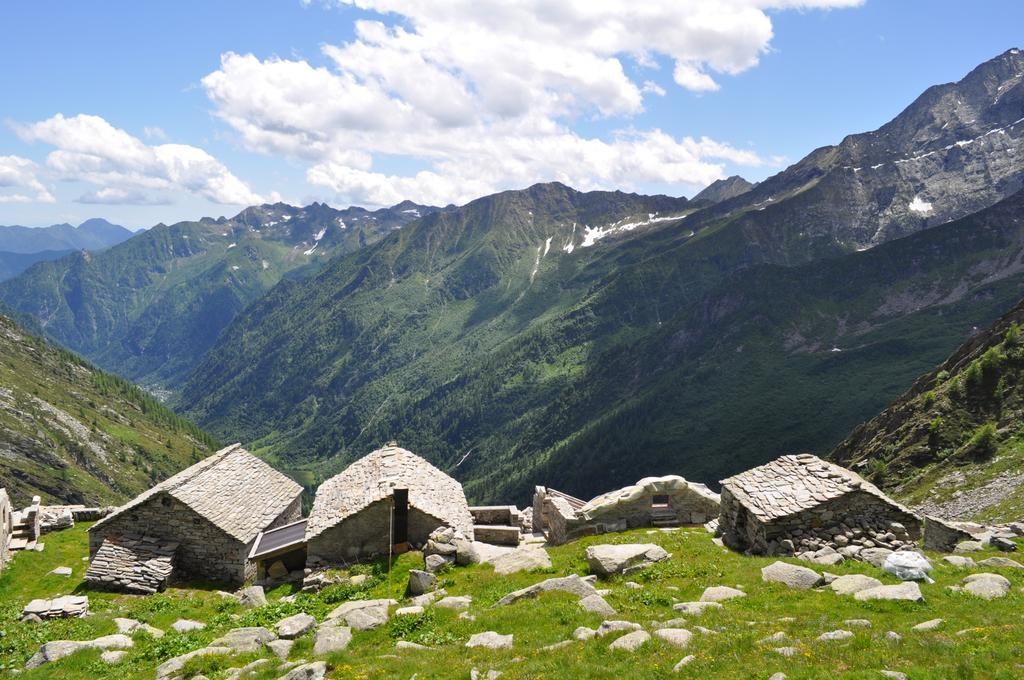What type of vegetation is present in the image? There is grass in the image. How many houses can be seen in the image? There are 3 houses in the image. What other natural elements are visible in the image? There are rocks in the image. the image. What can be seen in the distance in the image? There are mountains in the background of the image, and the sky is clear. What type of throat-soothing remedy is present in the image? There is no throat-soothing remedy present in the image. Can you describe the bun that is being served with the houses in the image? There is no bun present in the image; it features grass, houses, rocks, mountains, and a clear sky. 